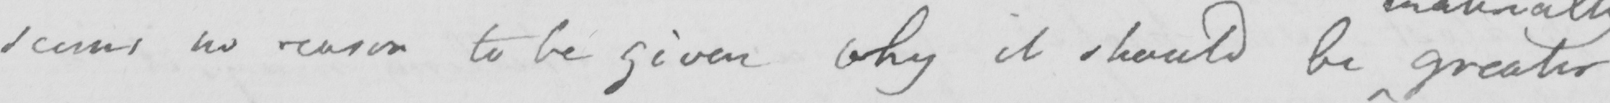Can you tell me what this handwritten text says? seems no reason to be given why it should be greater 